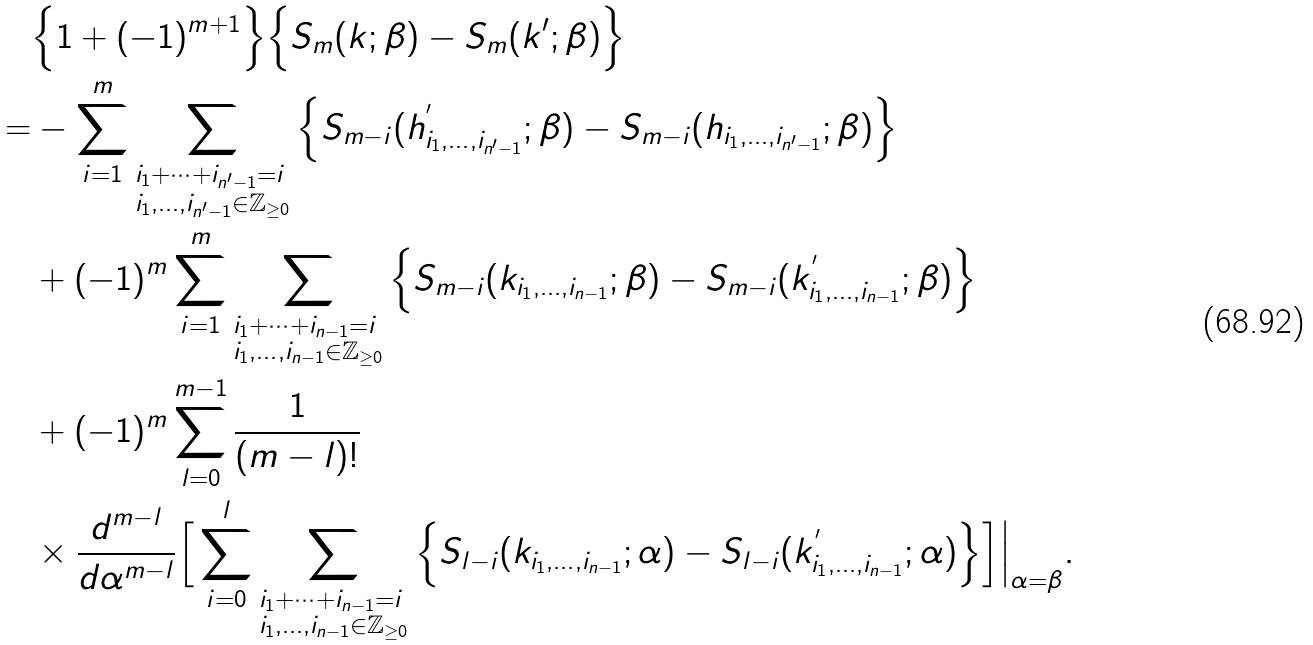Convert formula to latex. <formula><loc_0><loc_0><loc_500><loc_500>& \Big \{ 1 + ( - 1 ) ^ { m + 1 } \Big \} \Big \{ S _ { m } ( k ; \beta ) - S _ { m } ( k ^ { \prime } ; \beta ) \Big \} \\ = & - \sum _ { i = 1 } ^ { m } \sum _ { \begin{subarray} { c } i _ { 1 } + \cdots + i _ { n ^ { \prime } - 1 } = i \\ i _ { 1 } , \dots , i _ { n ^ { \prime } - 1 } \in \mathbb { Z } _ { \geq 0 } \end{subarray} } \Big \{ S _ { m - i } ( h ^ { ^ { \prime } } _ { i _ { 1 } , \dots , i _ { n ^ { \prime } - 1 } } ; \beta ) - S _ { m - i } ( h _ { i _ { 1 } , \dots , i _ { n ^ { \prime } - 1 } } ; \beta ) \Big \} \\ & + ( - 1 ) ^ { m } \sum _ { i = 1 } ^ { m } \sum _ { \begin{subarray} { c } i _ { 1 } + \cdots + i _ { n - 1 } = i \\ i _ { 1 } , \dots , i _ { n - 1 } \in \mathbb { Z } _ { \geq 0 } \end{subarray} } \Big \{ S _ { m - i } ( k _ { i _ { 1 } , \dots , i _ { n - 1 } } ; \beta ) - S _ { m - i } ( k ^ { ^ { \prime } } _ { i _ { 1 } , \dots , i _ { n - 1 } } ; \beta ) \Big \} \\ & + ( - 1 ) ^ { m } \sum _ { l = 0 } ^ { m - 1 } \frac { 1 } { ( m - l ) ! } \\ & \times \frac { d ^ { m - l } } { d \alpha ^ { m - l } } \Big [ \sum _ { i = 0 } ^ { l } \sum _ { \begin{subarray} { c } i _ { 1 } + \cdots + i _ { n - 1 } = i \\ i _ { 1 } , \dots , i _ { n - 1 } \in \mathbb { Z } _ { \geq 0 } \end{subarray} } \Big \{ S _ { l - i } ( k _ { i _ { 1 } , \dots , i _ { n - 1 } } ; \alpha ) - S _ { l - i } ( k ^ { ^ { \prime } } _ { i _ { 1 } , \dots , i _ { n - 1 } } ; \alpha ) \Big \} { \Big ] } { \Big | } _ { \alpha = \beta } .</formula> 